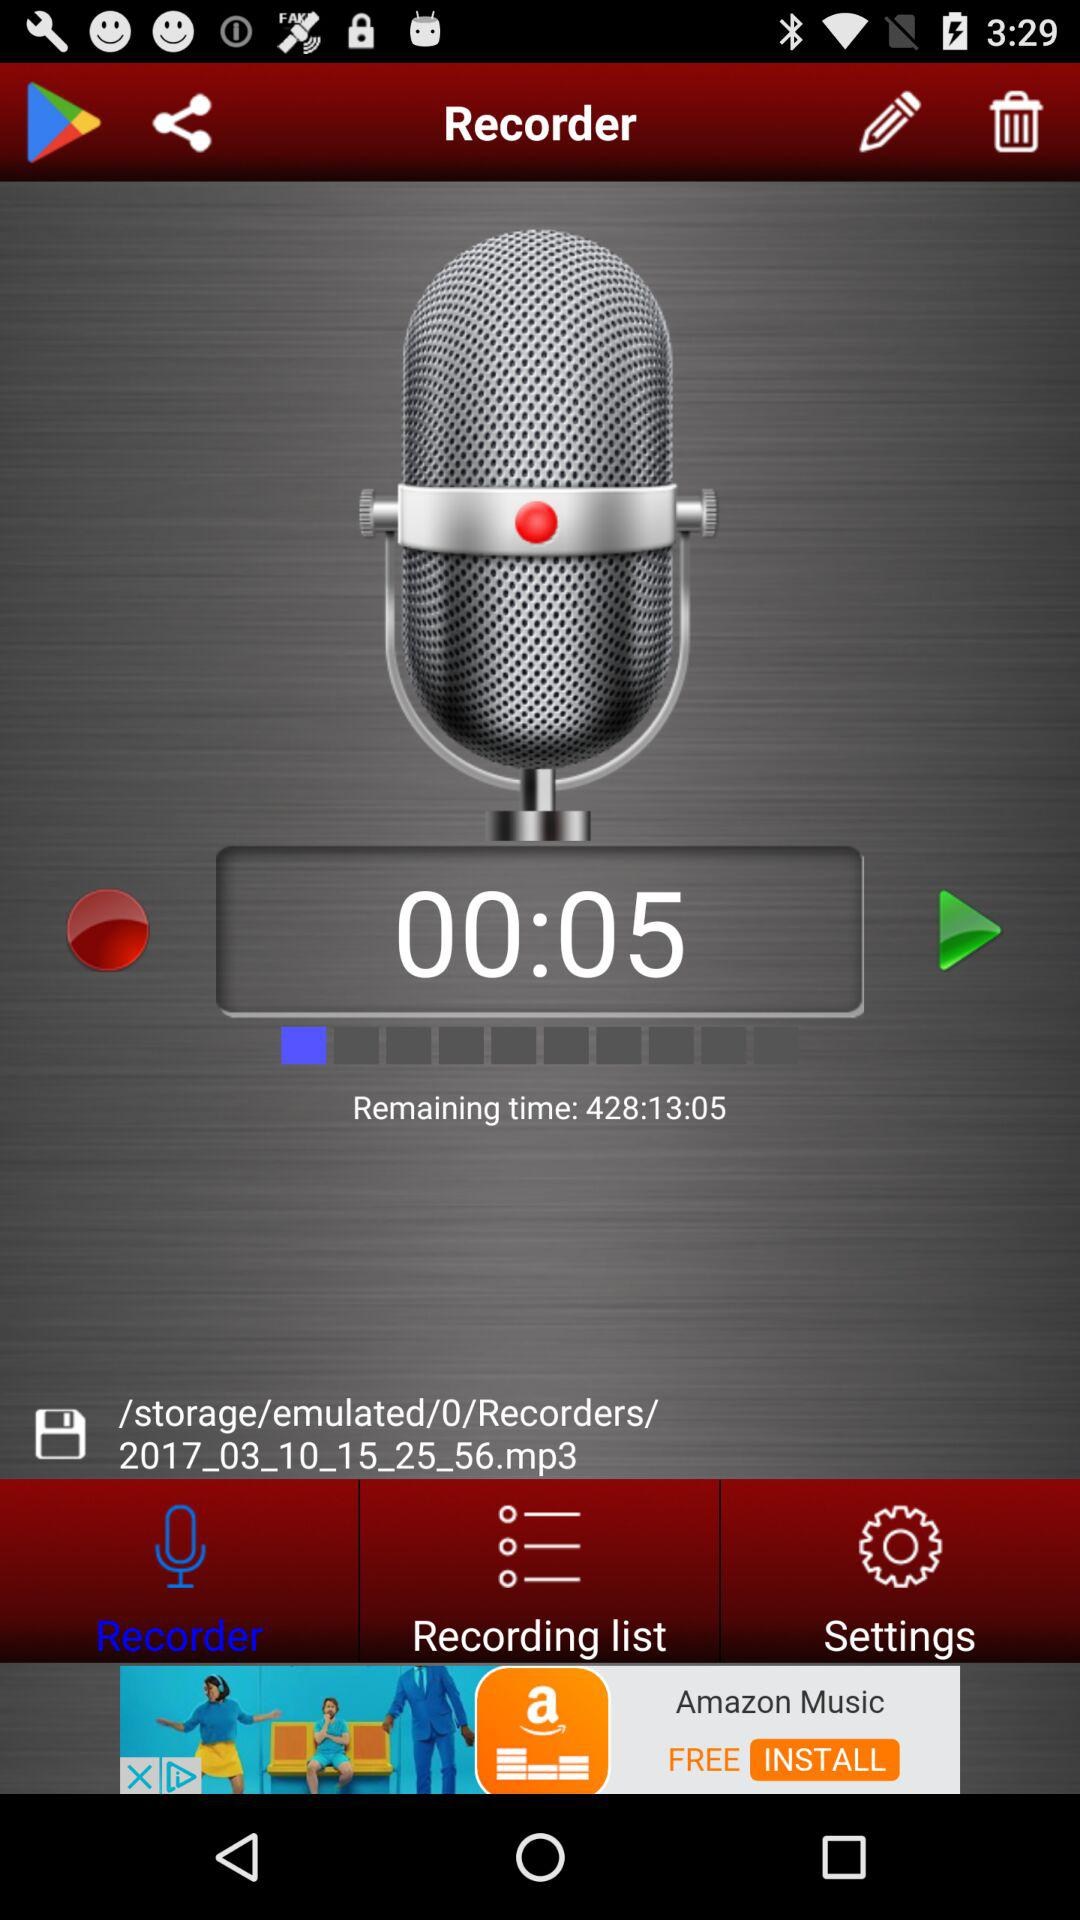How long will the recording play? The recording will play for 428:13:05. 